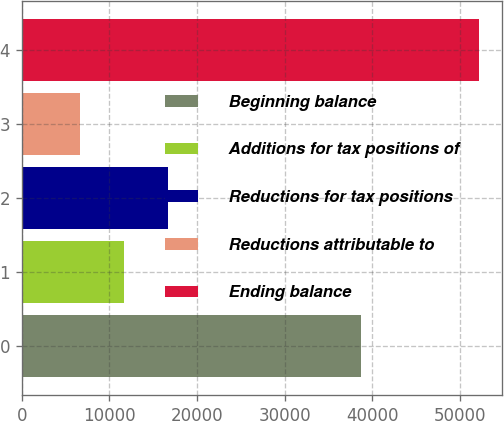<chart> <loc_0><loc_0><loc_500><loc_500><bar_chart><fcel>Beginning balance<fcel>Additions for tax positions of<fcel>Reductions for tax positions<fcel>Reductions attributable to<fcel>Ending balance<nl><fcel>38678<fcel>11666.6<fcel>16731.9<fcel>6601.3<fcel>52189<nl></chart> 